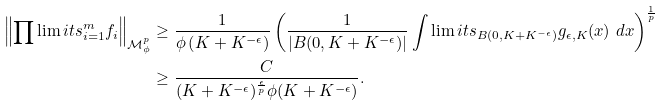<formula> <loc_0><loc_0><loc_500><loc_500>\left \| \prod \lim i t s _ { i = 1 } ^ { m } f _ { i } \right \| _ { \mathcal { M } ^ { p } _ { \phi } } & \geq \frac { 1 } { \phi \left ( K + K ^ { - \epsilon } \right ) } \left ( \frac { 1 } { | B ( 0 , K + K ^ { - \epsilon } ) | } \int \lim i t s _ { B ( 0 , K + K ^ { - \epsilon } ) } g _ { \epsilon , K } ( x ) \ d x \right ) ^ { \frac { 1 } { p } } \\ & \geq \frac { C } { ( K + K ^ { - \epsilon } ) ^ { \frac { \epsilon } { p } } \phi ( K + K ^ { - \epsilon } ) } .</formula> 